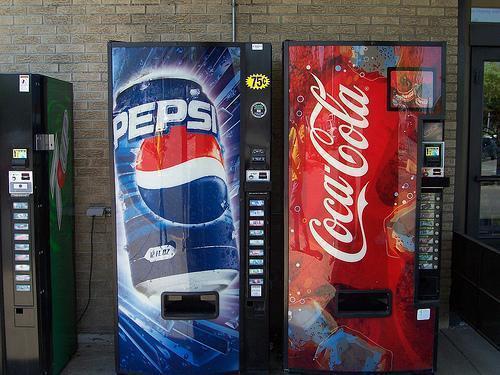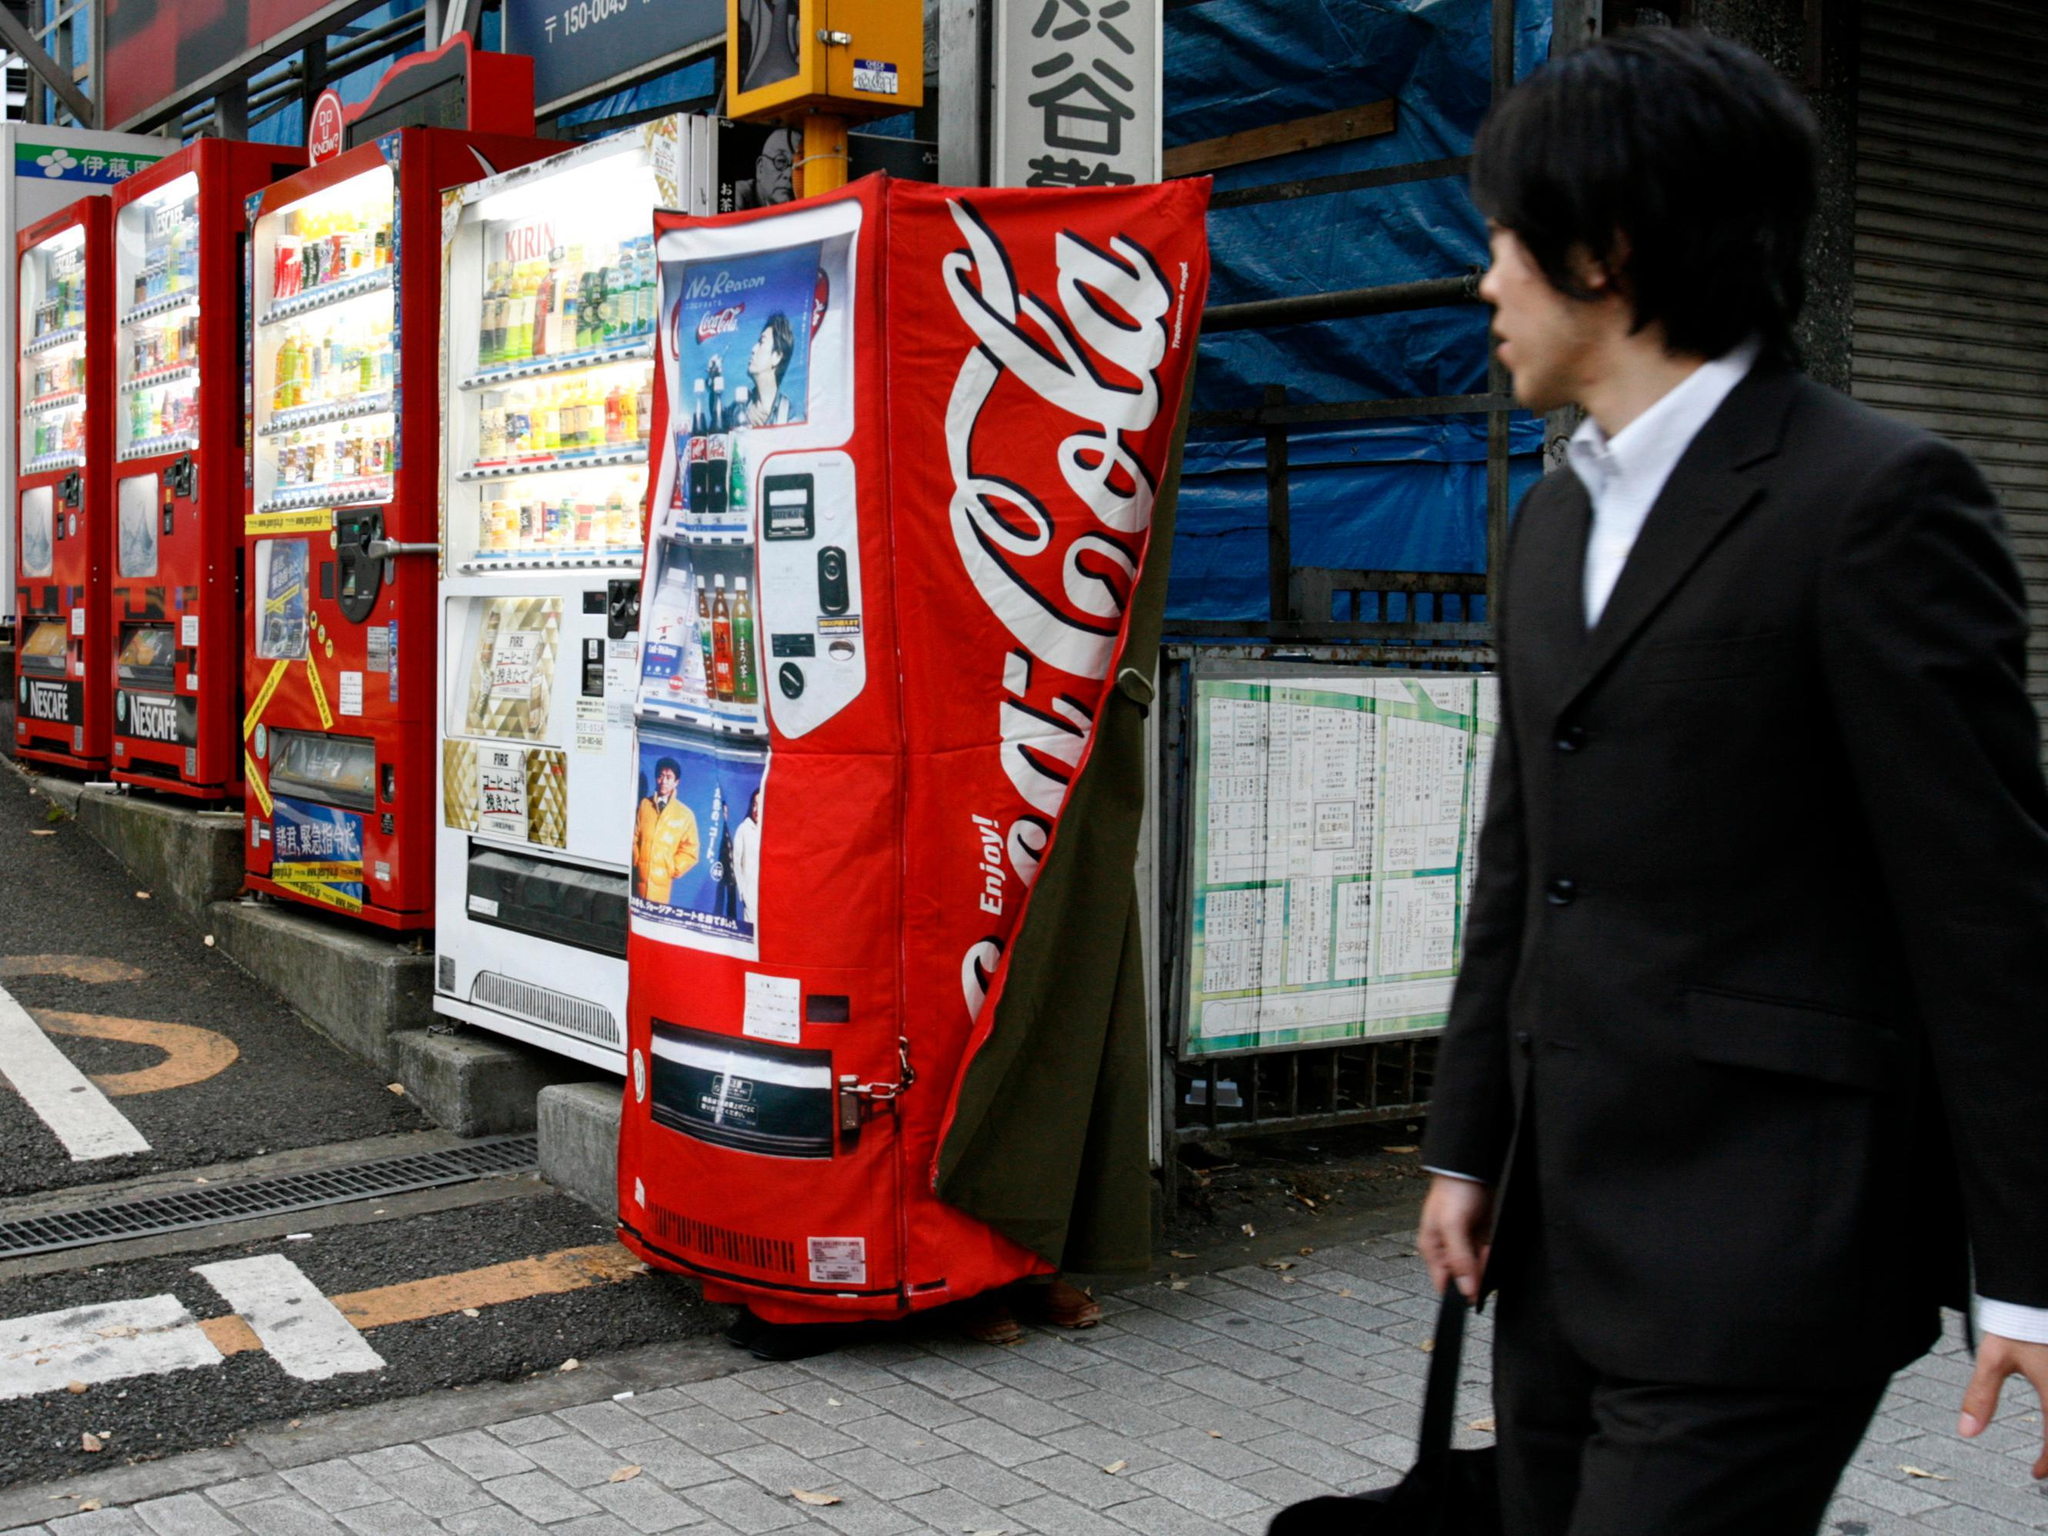The first image is the image on the left, the second image is the image on the right. Considering the images on both sides, is "At least one image contains a vending machine that is mostly red in color." valid? Answer yes or no. Yes. The first image is the image on the left, the second image is the image on the right. Evaluate the accuracy of this statement regarding the images: "The right image only has one vending machine.". Is it true? Answer yes or no. No. 